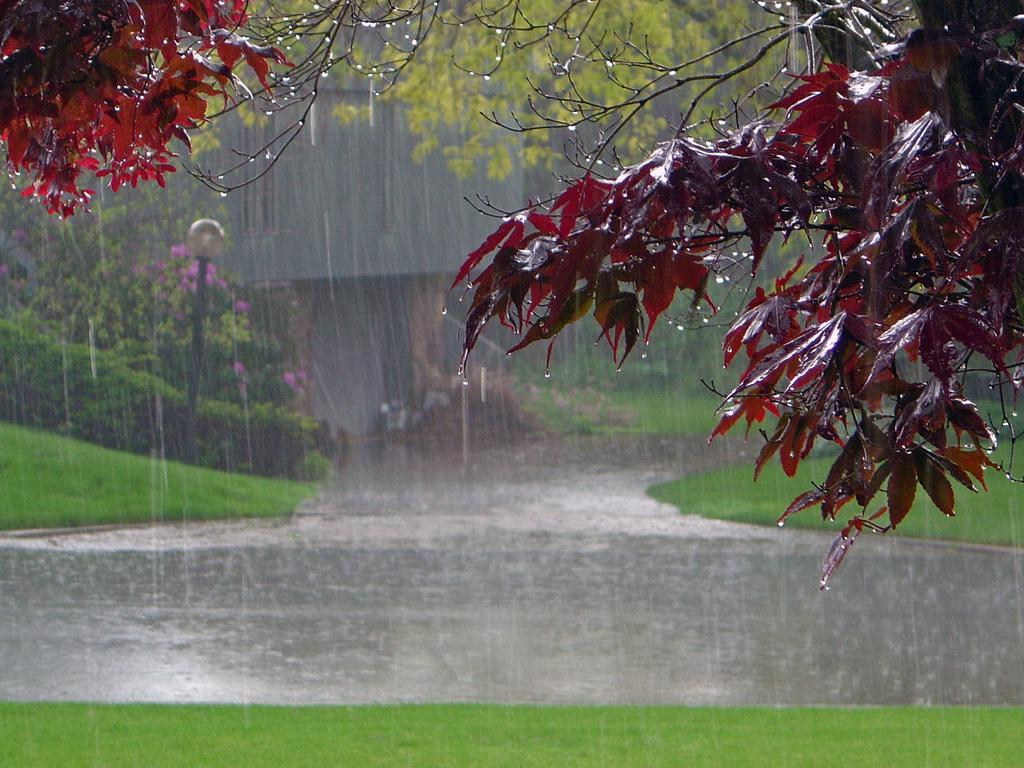What type of vegetation can be seen in the image? There are trees and flowers in the image. What is covering the road in the image? There is grass on the road in the image. What is the weather like in the image? It appears to be raining in the image. What can be seen in the background of the image? There is a building in the background of the image. What is the tall, vertical object in the image? There is a light pole in the image. What type of pancake is being served on the light pole in the image? There is no pancake present in the image, and the light pole is not serving any food. What is the source of fear in the image? There is no indication of fear or any fear-inducing elements in the image. 